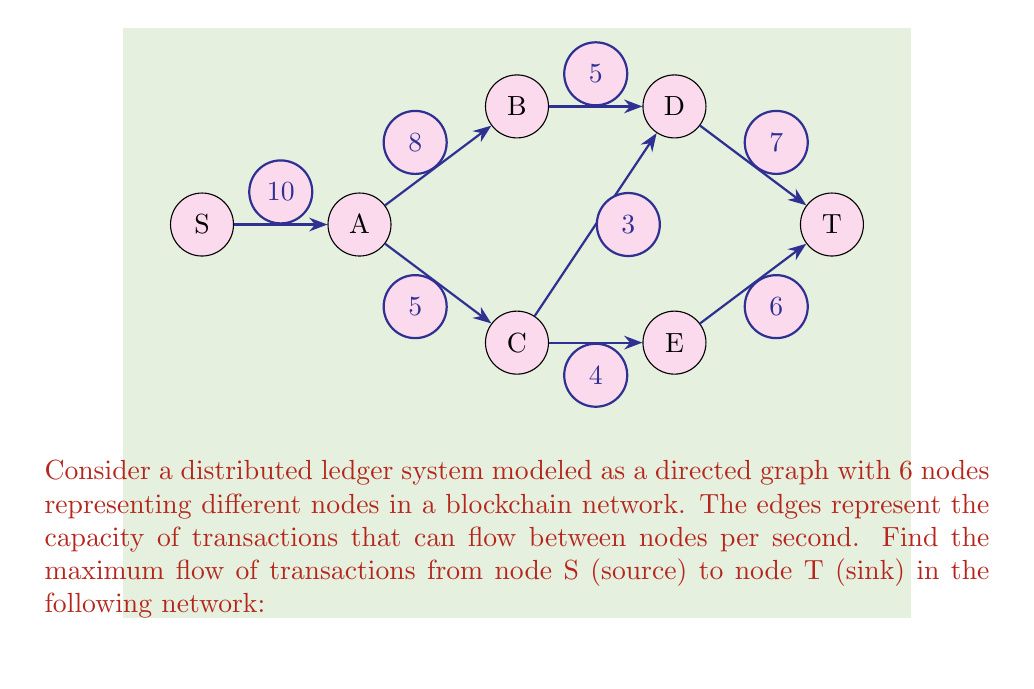Can you solve this math problem? To solve this maximum flow problem, we'll use the Ford-Fulkerson algorithm:

1) Initialize flow to 0 for all edges.

2) Find an augmenting path from S to T:
   Path 1: S -> A -> B -> D -> T (min capacity = 5)
   Update flow: f(S,A) = 5, f(A,B) = 5, f(B,D) = 5, f(D,T) = 5
   Residual capacities: c(S,A) = 5, c(A,B) = 3, c(B,D) = 0, c(D,T) = 2

3) Find another augmenting path:
   Path 2: S -> A -> C -> E -> T (min capacity = 4)
   Update flow: f(S,A) = 9, f(A,C) = 4, f(C,E) = 4, f(E,T) = 4
   Residual capacities: c(S,A) = 1, c(A,C) = 1, c(C,E) = 0, c(E,T) = 2

4) Find another augmenting path:
   Path 3: S -> A -> C -> D -> T (min capacity = 1)
   Update flow: f(S,A) = 10, f(A,C) = 5, f(C,D) = 1, f(D,T) = 6
   Residual capacities: c(S,A) = 0, c(A,C) = 0, c(C,D) = 2, c(D,T) = 1

5) No more augmenting paths exist.

The maximum flow is the sum of flows into T:
$$\text{Max Flow} = f(D,T) + f(E,T) = 6 + 4 = 10$$

This represents the maximum number of transactions per second that can flow through this distributed ledger system from source to sink.
Answer: 10 transactions per second 